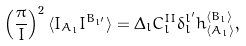Convert formula to latex. <formula><loc_0><loc_0><loc_500><loc_500>\left ( \frac { \pi } { I } \right ) ^ { 2 } \langle I _ { A _ { l } } I ^ { B _ { l ^ { \prime } } } \rangle = \Delta _ { l } C _ { l } ^ { I I } \delta _ { l } ^ { l ^ { \prime } } h _ { \langle A _ { l } \rangle } ^ { \langle B _ { l } \rangle } ,</formula> 